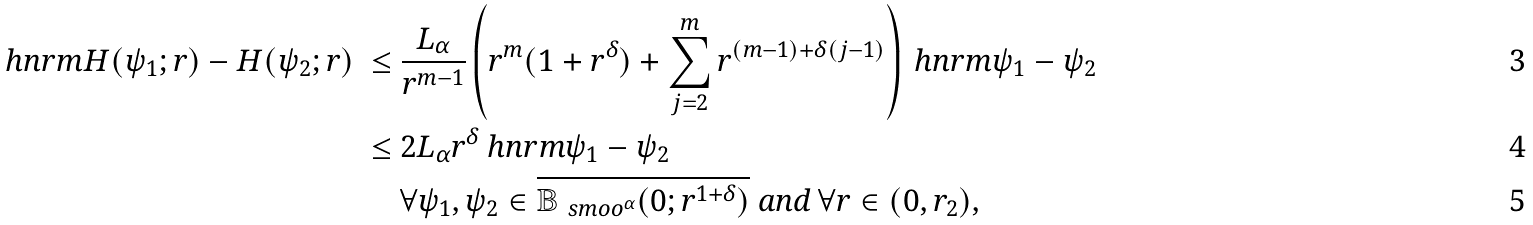Convert formula to latex. <formula><loc_0><loc_0><loc_500><loc_500>\ h n r m { H ( \psi _ { 1 } ; r ) - H ( \psi _ { 2 } ; r ) } \ \leq & \ \frac { L _ { \alpha } } { r ^ { m - 1 } } \left ( r ^ { m } ( 1 + r ^ { \delta } ) + \sum _ { j = 2 } ^ { m } r ^ { ( m - 1 ) + \delta ( j - 1 ) } \right ) \ h n r m { \psi _ { 1 } - \psi _ { 2 } } \\ \leq & \ 2 L _ { \alpha } r ^ { \delta } \ h n r m { \psi _ { 1 } - \psi _ { 2 } } \\ & \ \forall \psi _ { 1 } , \psi _ { 2 } \in \overline { \mathbb { B } _ { \ s m o o ^ { \alpha } } ( 0 ; r ^ { 1 + \delta } ) } \ \text {\em and} \ \forall r \in ( 0 , r _ { 2 } ) ,</formula> 